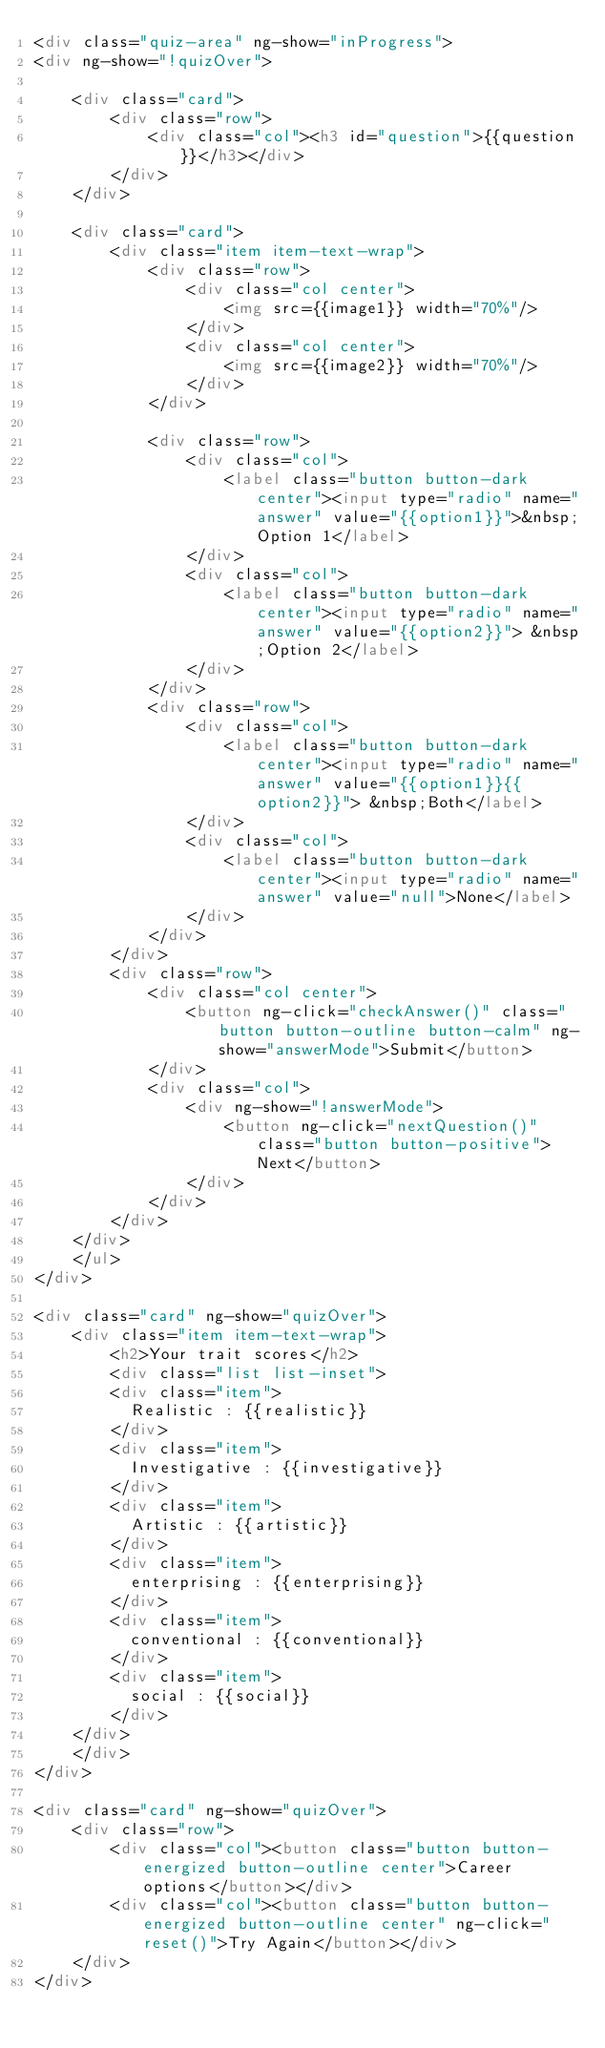Convert code to text. <code><loc_0><loc_0><loc_500><loc_500><_HTML_><div class="quiz-area" ng-show="inProgress">
<div ng-show="!quizOver">
	
	<div class="card">
		<div class="row">
			<div class="col"><h3 id="question">{{question}}</h3></div>
		</div>
	</div>
	
	<div class="card">
		<div class="item item-text-wrap">
			<div class="row">
				<div class="col center">
					<img src={{image1}} width="70%"/>
				</div>
				<div class="col center">
					<img src={{image2}} width="70%"/>
				</div>
			</div>

			<div class="row">
				<div class="col">
					<label class="button button-dark center"><input type="radio" name="answer" value="{{option1}}">&nbsp;Option 1</label>	
				</div>
				<div class="col">
					<label class="button button-dark center"><input type="radio" name="answer" value="{{option2}}"> &nbsp;Option 2</label>
				</div>
			</div>
			<div class="row">
				<div class="col">
					<label class="button button-dark center"><input type="radio" name="answer" value="{{option1}}{{option2}}"> &nbsp;Both</label>	
				</div>
				<div class="col">
					<label class="button button-dark center"><input type="radio" name="answer" value="null">None</label>
				</div>
			</div>		
		</div>
		<div class="row">
			<div class="col center">
				<button ng-click="checkAnswer()" class="button button-outline button-calm" ng-show="answerMode">Submit</button>
			</div>
			<div class="col">
				<div ng-show="!answerMode">
					<button ng-click="nextQuestion()" class="button button-positive">Next</button>
				</div>
			</div>
		</div>
	</div>
	</ul>
</div>

<div class="card" ng-show="quizOver">
	<div class="item item-text-wrap">
		<h2>Your trait scores</h2>
		<div class="list list-inset">
	    <div class="item">
	      Realistic : {{realistic}}
	    </div>
	    <div class="item">
	      Investigative : {{investigative}}
	    </div>
	    <div class="item">
	      Artistic : {{artistic}}
	    </div>
	    <div class="item">
	      enterprising : {{enterprising}}
	    </div>
	    <div class="item">
	      conventional : {{conventional}}
	    </div>
	    <div class="item">
	      social : {{social}}
	    </div>
	</div>
	</div>
</div>

<div class="card" ng-show="quizOver">
	<div class="row">
		<div class="col"><button class="button button-energized button-outline center">Career options</button></div>
		<div class="col"><button class="button button-energized button-outline center" ng-click="reset()">Try Again</button></div>
	</div>
</div></code> 